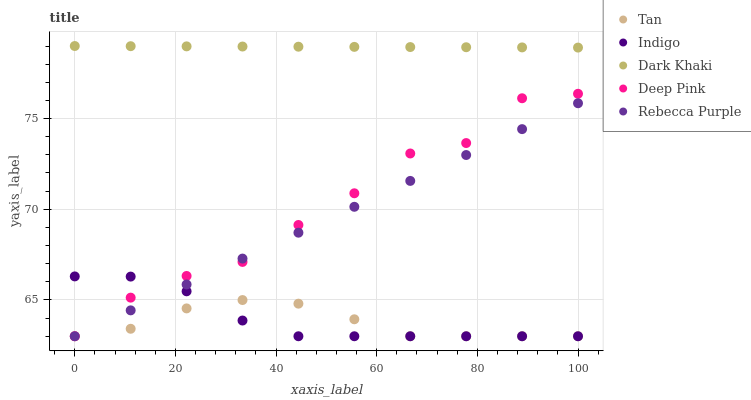Does Tan have the minimum area under the curve?
Answer yes or no. Yes. Does Dark Khaki have the maximum area under the curve?
Answer yes or no. Yes. Does Deep Pink have the minimum area under the curve?
Answer yes or no. No. Does Deep Pink have the maximum area under the curve?
Answer yes or no. No. Is Rebecca Purple the smoothest?
Answer yes or no. Yes. Is Deep Pink the roughest?
Answer yes or no. Yes. Is Tan the smoothest?
Answer yes or no. No. Is Tan the roughest?
Answer yes or no. No. Does Tan have the lowest value?
Answer yes or no. Yes. Does Dark Khaki have the highest value?
Answer yes or no. Yes. Does Deep Pink have the highest value?
Answer yes or no. No. Is Indigo less than Dark Khaki?
Answer yes or no. Yes. Is Dark Khaki greater than Indigo?
Answer yes or no. Yes. Does Rebecca Purple intersect Tan?
Answer yes or no. Yes. Is Rebecca Purple less than Tan?
Answer yes or no. No. Is Rebecca Purple greater than Tan?
Answer yes or no. No. Does Indigo intersect Dark Khaki?
Answer yes or no. No. 